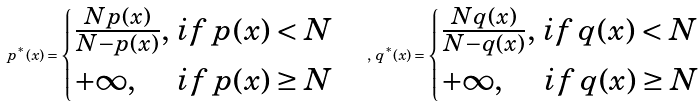Convert formula to latex. <formula><loc_0><loc_0><loc_500><loc_500>p ^ { \ast } ( x ) = \begin{cases} \frac { N p ( x ) } { N - p ( x ) } , \, i f \, p ( x ) < N \\ + \infty , \, \quad \, i f \, p ( x ) \geq N \end{cases} , \, q ^ { \ast } ( x ) = \begin{cases} \frac { N q ( x ) } { N - q ( x ) } , \, i f \, q ( x ) < N \\ + \infty , \, \quad \, i f \, q ( x ) \geq N \end{cases}</formula> 